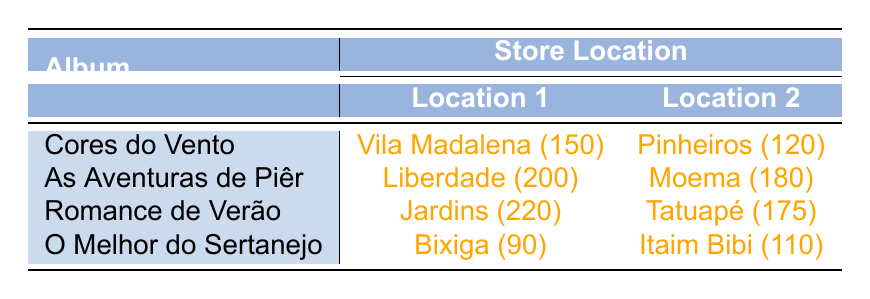What is the highest merchandise sale for any album? The highest merchandise sale in the table is 220 from the album "Romance de Verão" at the location "Jardins."
Answer: 220 Which store location sold fewer items for "Cores do Vento"? Comparing the sales locations for "Cores do Vento," "Pinheiros" has 120 sales, while "Vila Madalena" has 150 sales. Therefore, "Pinheiros" sold fewer items.
Answer: Pinheiros What is the total merchandise sales for "As Aventuras de Piêr"? For "As Aventuras de Piêr," the sales are 200 in "Liberdade" and 180 in "Moema." Summing these gives us a total of 200 + 180 = 380.
Answer: 380 Is the merchandise sales for "O Melhor do Sertanejo" greater than 200? The sales are 90 in "Bixiga" and 110 in "Itaim Bibi," which totals to 90 + 110 = 200. Since 200 is not greater than 200, the statement is false.
Answer: No What is the average merchandise sales for "Romance de Verão"? For "Romance de Verão," there are two sales figures: 220 in "Jardins" and 175 in "Tatuapé." The average is (220 + 175) / 2 = 395 / 2 = 197.5.
Answer: 197.5 Which album has the least sales in the table? By examining all the albums, "O Melhor do Sertanejo" has total sales of 90 in "Bixiga" and 110 in "Itaim Bibi," giving a total of 200, which is less than all the other albums.
Answer: O Melhor do Sertanejo What is the combined sales for "Romance de Verão" and "As Aventuras de Piêr"? "Romance de Verão" has sales of 220 + 175 = 395, while "As Aventuras de Piêr" has 200 + 180 = 380. Adding these totals gives 395 + 380 = 775.
Answer: 775 Are the total sales for all locations in São Paulo above 1000? Adding all sales together: 150 + 120 + 200 + 180 + 220 + 175 + 90 + 110 = 1145. Since 1145 is greater than 1000, the statement is true.
Answer: Yes 